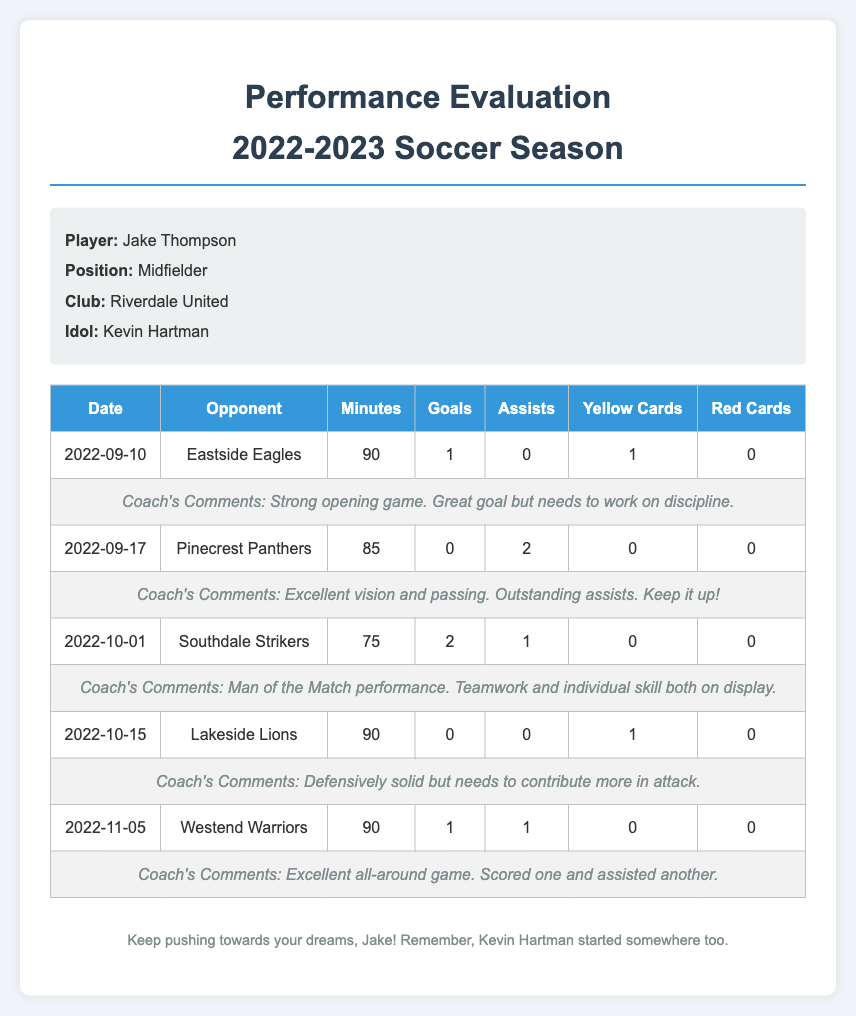What is the player's name? The player's name is mentioned in the player info section of the document.
Answer: Jake Thompson What position does the player play? The position of the player is indicated in the player info section.
Answer: Midfielder How many goals did Jake score against Southdale Strikers? The number of goals scored against Southdale Strikers is provided in the statistics table.
Answer: 2 What was the date of the game against Eastside Eagles? The game date against Eastside Eagles is listed in the statistics table.
Answer: 2022-09-10 What comment did the coach make about the game on October 15? The coach's comments for the game on October 15 are included in the document.
Answer: Defensively solid but needs to contribute more in attack Which opponent did Jake play against last? The last opponent mentioned in the statistics table is the most recent game played by the player.
Answer: Westend Warriors How many total assists did Jake have in the game against Pinecrest Panthers? The number of assists in the game against Pinecrest Panthers is listed in the statistics table.
Answer: 2 Who is Jake's idol? The idol of the player is stated in the player info section.
Answer: Kevin Hartman What was the total number of yellow cards received by Jake in the documented games? The total yellow cards are calculated by adding yellow cards from all games in the statistics table.
Answer: 2 